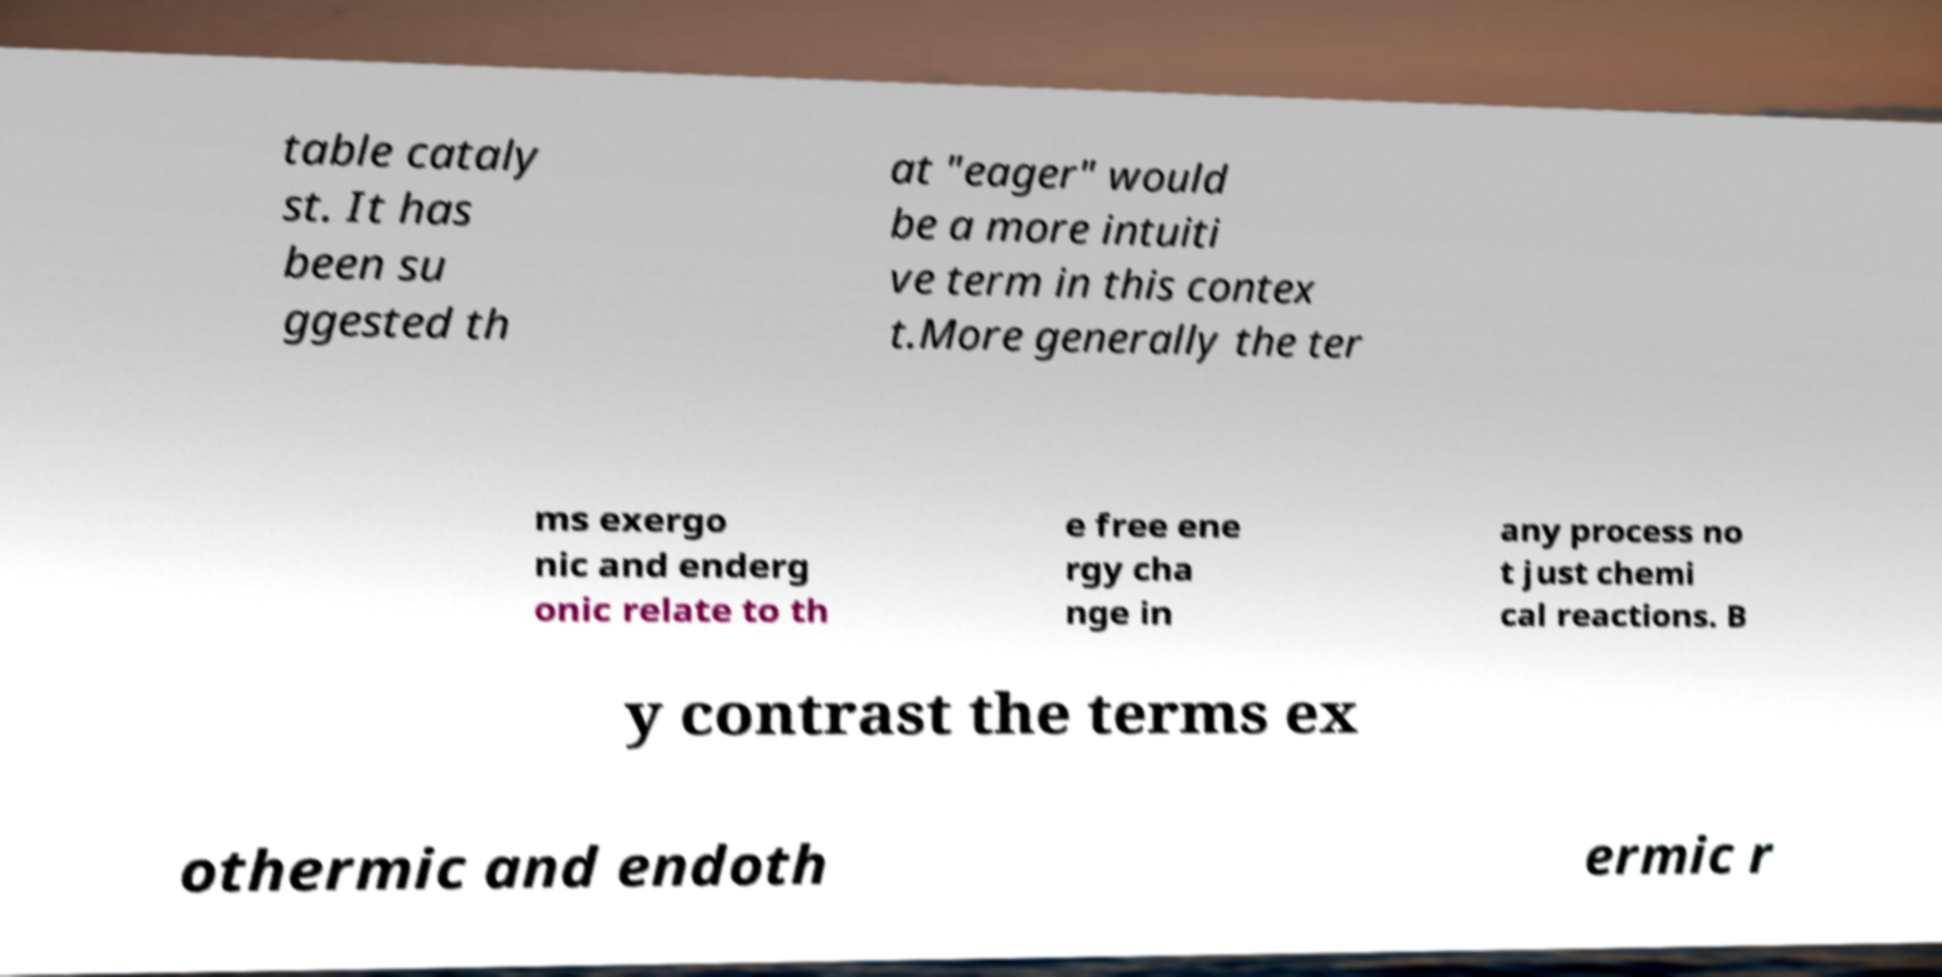Please read and relay the text visible in this image. What does it say? table cataly st. It has been su ggested th at "eager" would be a more intuiti ve term in this contex t.More generally the ter ms exergo nic and enderg onic relate to th e free ene rgy cha nge in any process no t just chemi cal reactions. B y contrast the terms ex othermic and endoth ermic r 